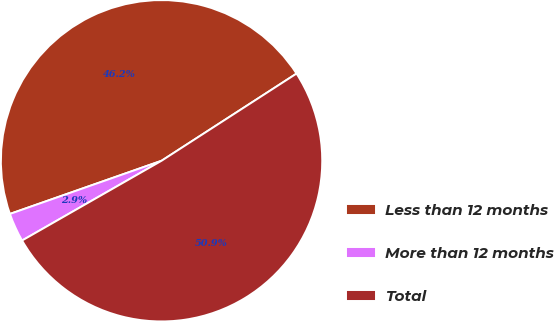Convert chart to OTSL. <chart><loc_0><loc_0><loc_500><loc_500><pie_chart><fcel>Less than 12 months<fcel>More than 12 months<fcel>Total<nl><fcel>46.24%<fcel>2.9%<fcel>50.86%<nl></chart> 